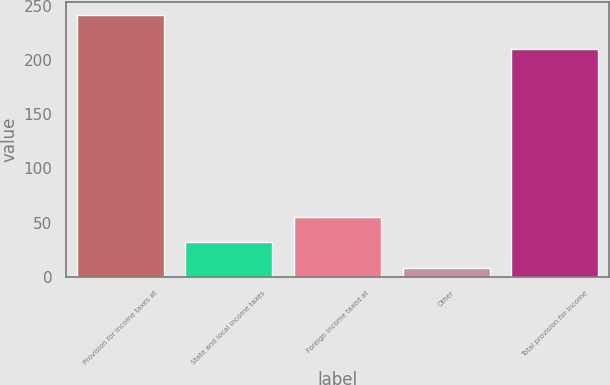Convert chart to OTSL. <chart><loc_0><loc_0><loc_500><loc_500><bar_chart><fcel>Provision for income taxes at<fcel>State and local income taxes<fcel>Foreign income taxed at<fcel>Other<fcel>Total provision for income<nl><fcel>241.3<fcel>31.69<fcel>54.98<fcel>8.4<fcel>209.8<nl></chart> 